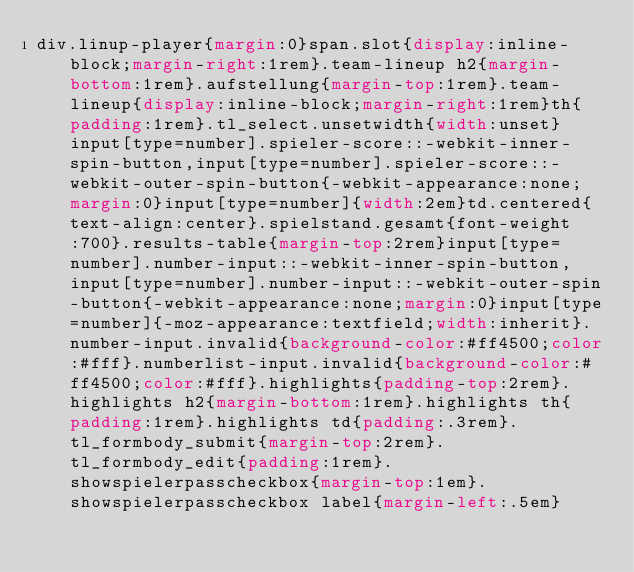<code> <loc_0><loc_0><loc_500><loc_500><_CSS_>div.linup-player{margin:0}span.slot{display:inline-block;margin-right:1rem}.team-lineup h2{margin-bottom:1rem}.aufstellung{margin-top:1rem}.team-lineup{display:inline-block;margin-right:1rem}th{padding:1rem}.tl_select.unsetwidth{width:unset}input[type=number].spieler-score::-webkit-inner-spin-button,input[type=number].spieler-score::-webkit-outer-spin-button{-webkit-appearance:none;margin:0}input[type=number]{width:2em}td.centered{text-align:center}.spielstand.gesamt{font-weight:700}.results-table{margin-top:2rem}input[type=number].number-input::-webkit-inner-spin-button,input[type=number].number-input::-webkit-outer-spin-button{-webkit-appearance:none;margin:0}input[type=number]{-moz-appearance:textfield;width:inherit}.number-input.invalid{background-color:#ff4500;color:#fff}.numberlist-input.invalid{background-color:#ff4500;color:#fff}.highlights{padding-top:2rem}.highlights h2{margin-bottom:1rem}.highlights th{padding:1rem}.highlights td{padding:.3rem}.tl_formbody_submit{margin-top:2rem}.tl_formbody_edit{padding:1rem}.showspielerpasscheckbox{margin-top:1em}.showspielerpasscheckbox label{margin-left:.5em}</code> 